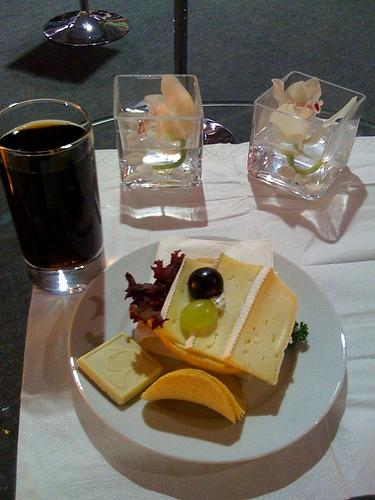What kind of chips are served on the plate? pringles 